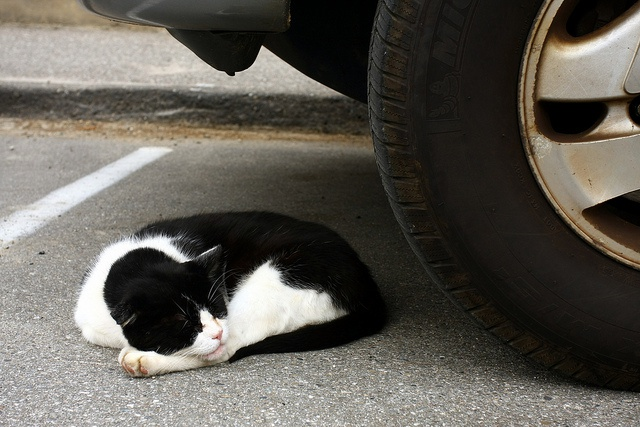Describe the objects in this image and their specific colors. I can see car in gray, black, and darkgray tones and cat in gray, black, white, and darkgray tones in this image. 